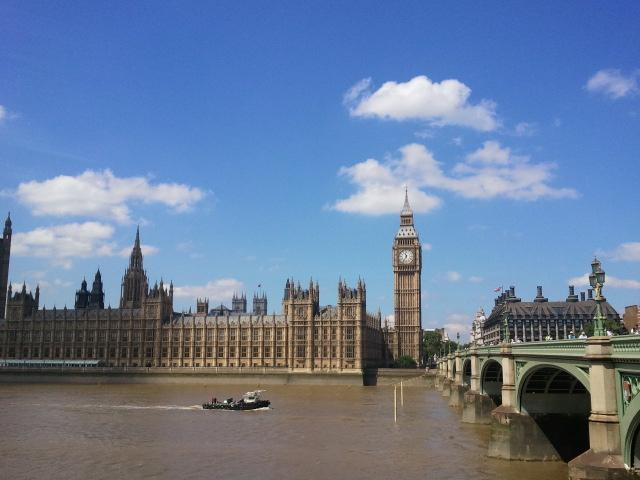What period of the day is shown in the image?

Choices:
A) night
B) afternoon
C) evening
D) morning morning 